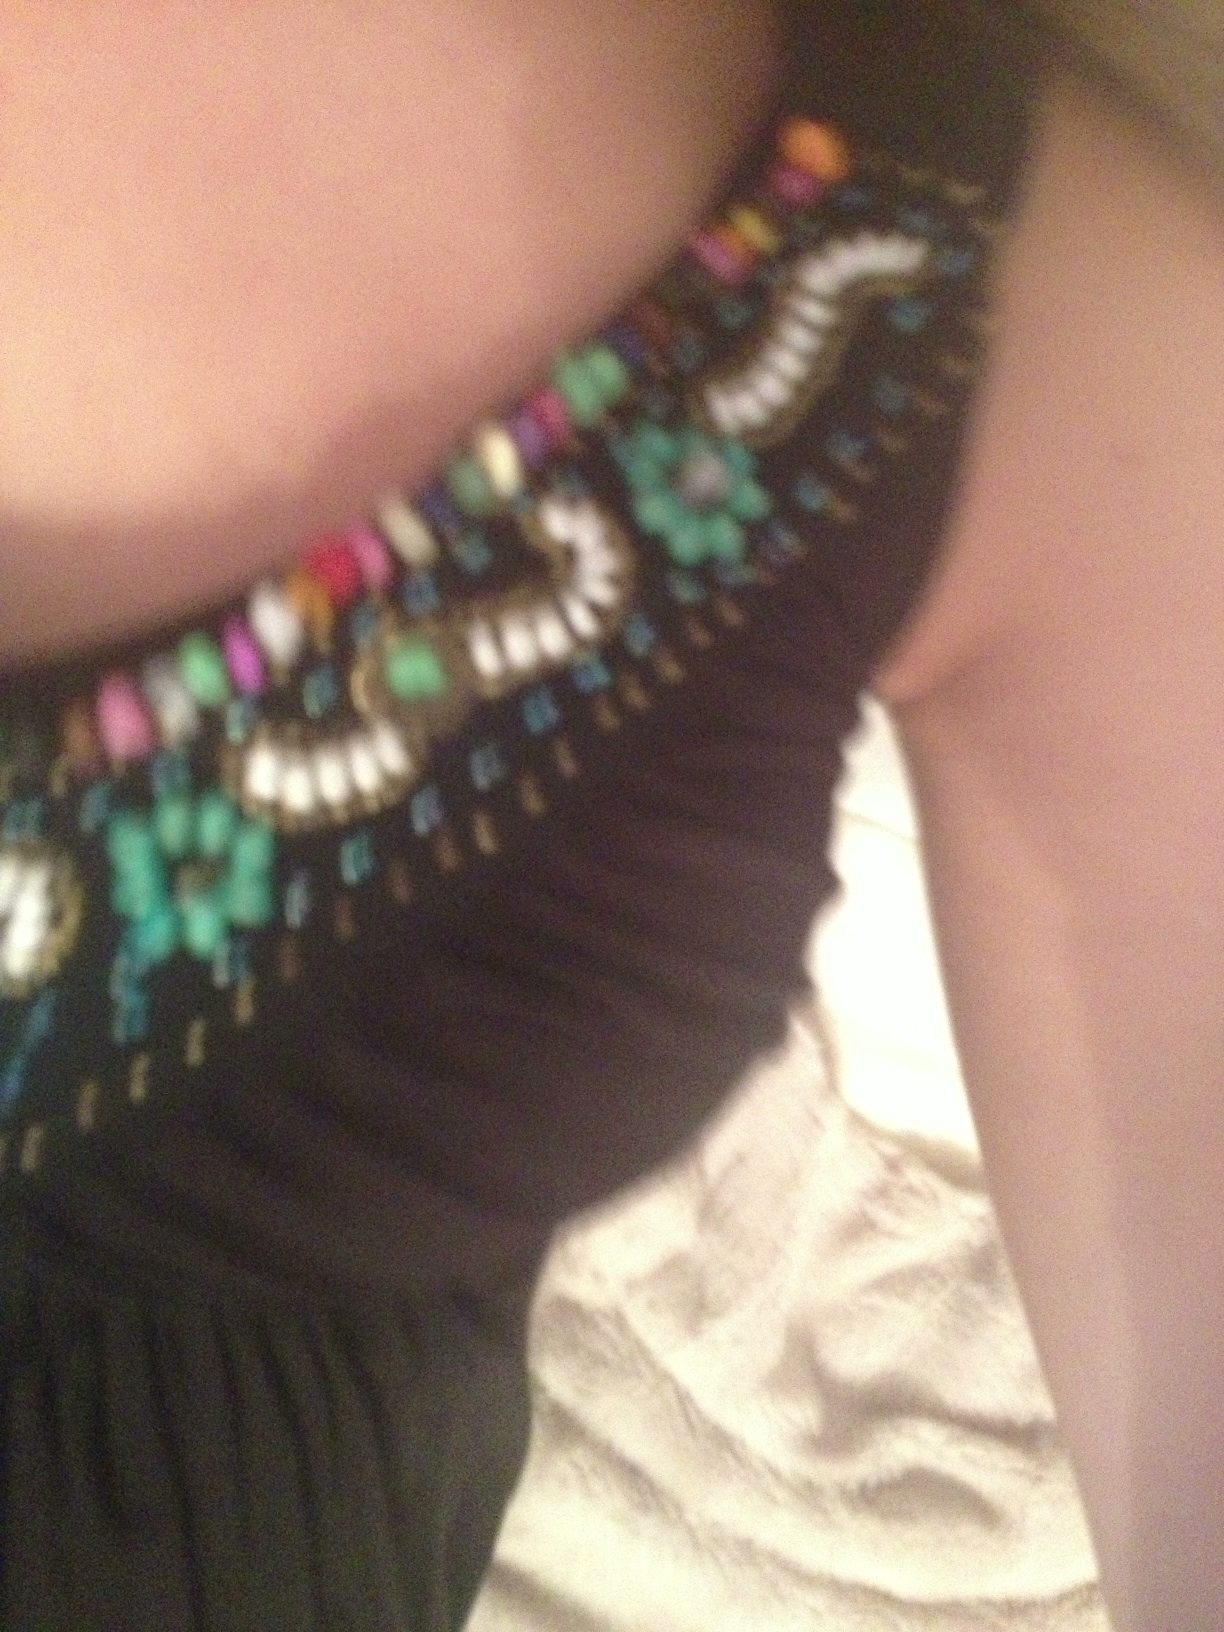What color earrings and sweater should I wear with this dress? Given the dress in the image, which appears to have a vibrant and multicolored embellishment at the neckline, I recommend choosing earrings and a sweater in a solid color that matches one of the more subdued hues in the embellishments, such as a dark emerald or navy blue. This approach will create a stylish and sophisticated look without overpowering the dress' detail. 